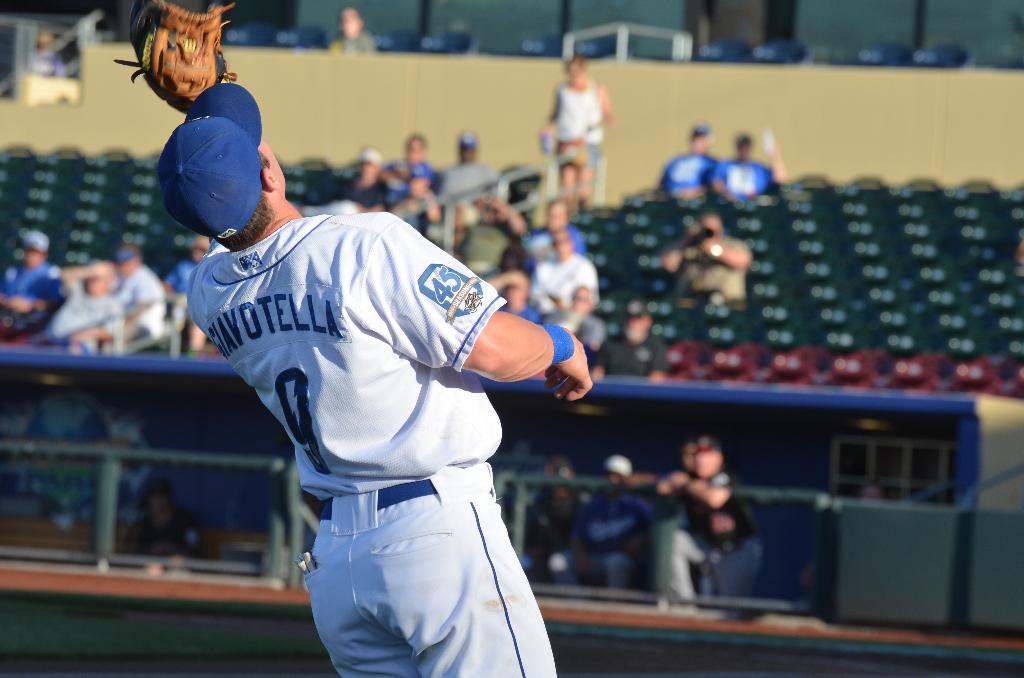That athlete have a name?
Ensure brevity in your answer.  Giavotella. What is the athlete's jersey number?
Your answer should be very brief. 9. 